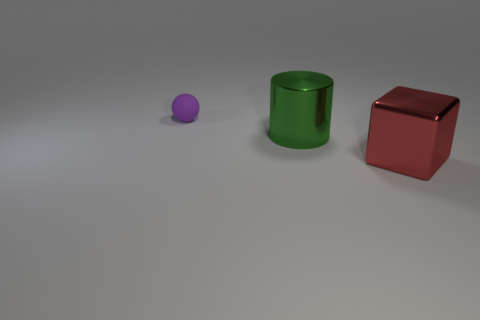Are there any other things that are the same material as the small ball?
Keep it short and to the point. No. What is the size of the metal thing that is behind the red thing?
Your response must be concise. Large. How many objects have the same size as the cylinder?
Offer a terse response. 1. There is a big object that is made of the same material as the big cylinder; what color is it?
Keep it short and to the point. Red. Are there fewer shiny things that are to the left of the red shiny cube than tiny purple balls?
Provide a succinct answer. No. There is a red thing that is the same material as the cylinder; what shape is it?
Keep it short and to the point. Cube. How many shiny objects are either tiny red blocks or big things?
Make the answer very short. 2. Are there an equal number of large green shiny cylinders that are to the right of the big green metal cylinder and things?
Your answer should be very brief. No. There is a shiny thing on the left side of the red object; is its color the same as the rubber ball?
Offer a terse response. No. What is the thing that is both left of the red shiny thing and in front of the purple object made of?
Give a very brief answer. Metal. 